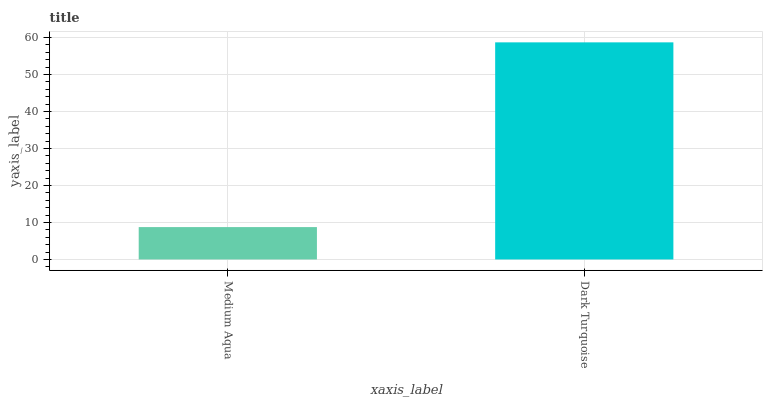Is Medium Aqua the minimum?
Answer yes or no. Yes. Is Dark Turquoise the maximum?
Answer yes or no. Yes. Is Dark Turquoise the minimum?
Answer yes or no. No. Is Dark Turquoise greater than Medium Aqua?
Answer yes or no. Yes. Is Medium Aqua less than Dark Turquoise?
Answer yes or no. Yes. Is Medium Aqua greater than Dark Turquoise?
Answer yes or no. No. Is Dark Turquoise less than Medium Aqua?
Answer yes or no. No. Is Dark Turquoise the high median?
Answer yes or no. Yes. Is Medium Aqua the low median?
Answer yes or no. Yes. Is Medium Aqua the high median?
Answer yes or no. No. Is Dark Turquoise the low median?
Answer yes or no. No. 